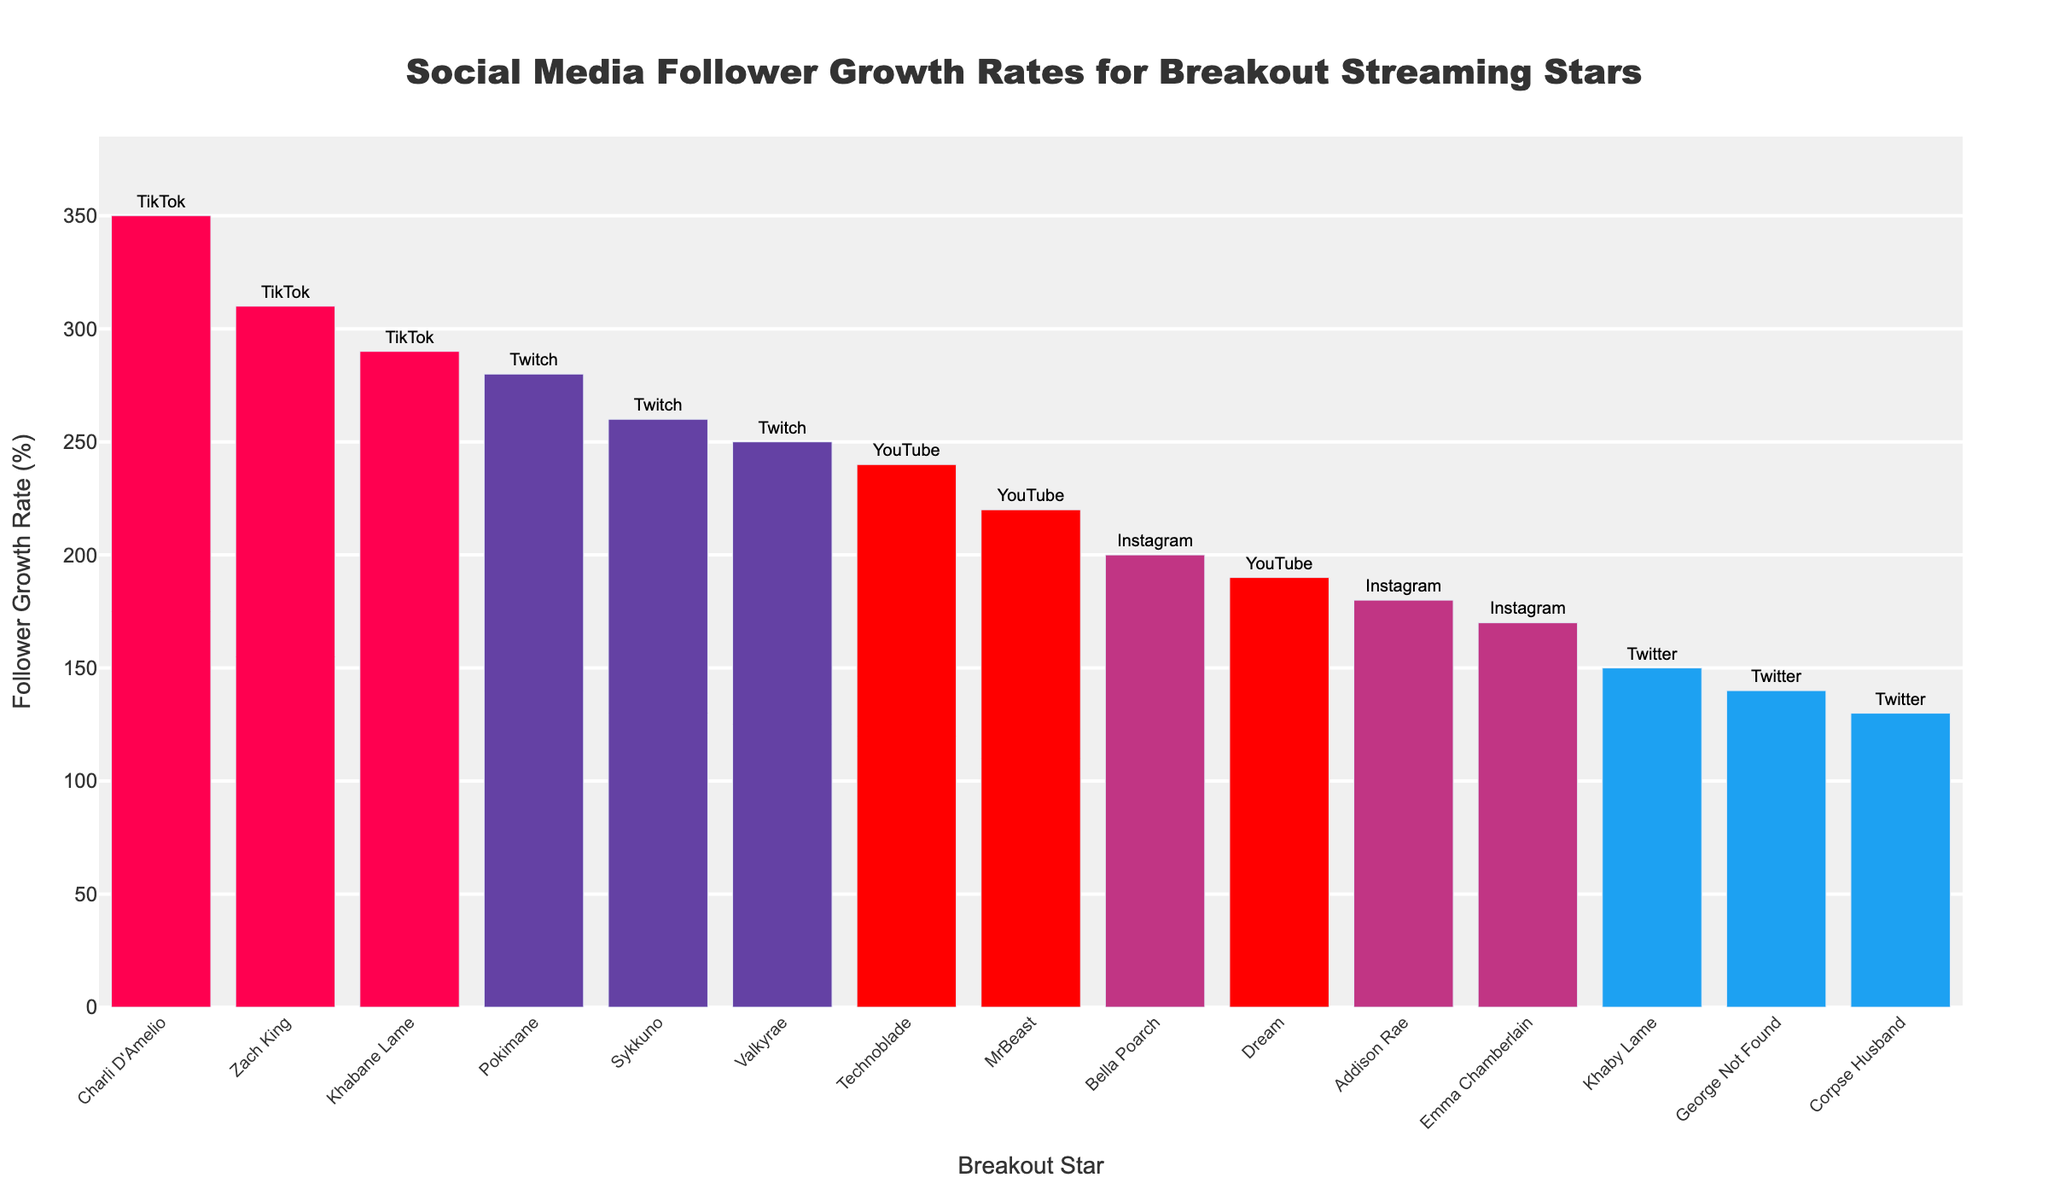Which breakout star has the highest follower growth rate? Charli D'Amelio has the highest follower growth rate as depicted by the tallest bar in the chart, indicating a 350% growth rate on TikTok.
Answer: Charli D'Amelio Which platform has the most breakout stars in the list? Instagram has the most breakout stars in the list with three entries: Addison Rae, Bella Poarch, and Emma Chamberlain.
Answer: Instagram What is the difference in follower growth rate between Pokimane and Valkyrae on Twitch? Pokimane has a 280% growth rate while Valkyrae has 250%. The difference between them is 280% - 250% = 30%.
Answer: 30% Which breakout star has a higher follower growth rate on Twitter: Khaby Lame or George Not Found? Khaby Lame has a 150% growth rate, while George Not Found has a 140% growth rate. Thus, Khaby Lame has a higher follower growth rate.
Answer: Khaby Lame What is the combined follower growth rate of all the Twitch breakout stars? The follower growth rates of the Twitch stars are 280% (Pokimane), 250% (Valkyrae), and 260% (Sykkuno). The combined rate is 280% + 250% + 260% = 790%.
Answer: 790% What's the average follower growth rate of breakout stars on YouTube? The follower growth rates on YouTube are 220% (MrBeast), 190% (Dream), and 240% (Technoblade). The average rate is (220% + 190% + 240%) / 3 = 650% / 3 ≈ 216.67%.
Answer: 216.67% Which platform's breakout stars have the largest range of follower growth rates? TikTok’s breakout stars have rates of 350% (Charli D'Amelio), 310% (Zach King), and 290% (Khabane Lame). The range is 350% - 290% = 60%.
Answer: TikTok Do breakout stars on Instagram exhibit growth rates closer to each other compared to those on YouTube? Instagram growth rates are 180%, 200%, 170%, yielding a range of 30%. YouTube growth rates are 220%, 190%, 240%, with a range of 50%. Instagram stars exhibit closer follower growth rates.
Answer: Yes Who has a higher follower growth rate on Instagram: Addison Rae or Bella Poarch? Addison Rae has a growth rate of 180%, while Bella Poarch has 200%. Therefore, Bella Poarch has a higher follower growth rate.
Answer: Bella Poarch 